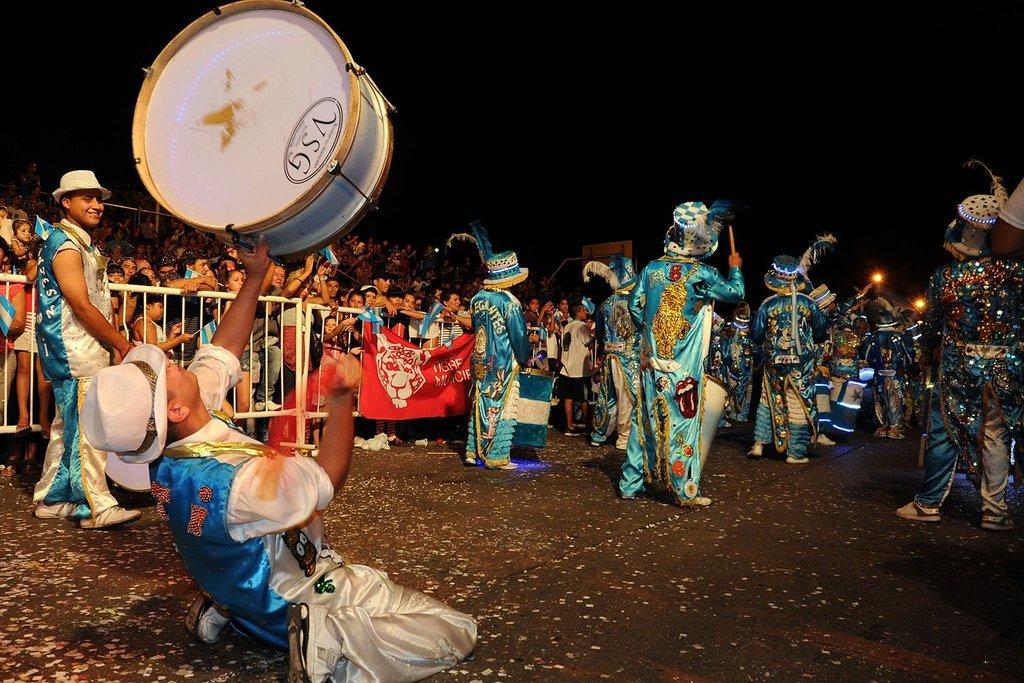Can you describe this image briefly? This is clicked outside. There are so many people in this image. Some are wearing Circus dresses and playing musical instruments and the other people who are on the left side are watching them. There is a drum on the top. 